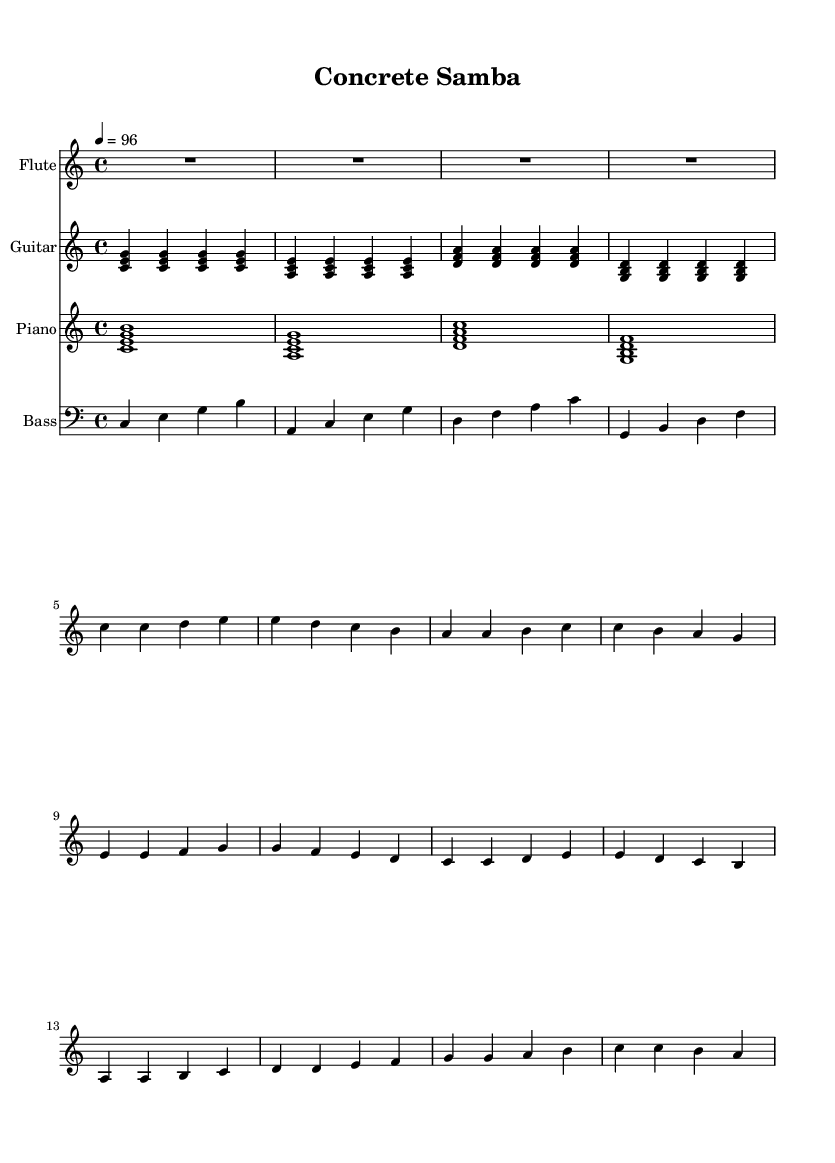What is the key signature of this music? The key signature is C major, indicated by the absence of sharps or flats.
Answer: C major What is the time signature of this piece? The time signature is found at the beginning of the score and shows 4/4, meaning there are four beats per measure.
Answer: 4/4 What is the tempo marking of this music? The tempo marking is indicated by "4 = 96", which means there are 96 beats per minute, suggesting a moderate pace.
Answer: 96 How many measures are in the flute part? By counting the distinct sections separated by the vertical bar lines, we find a total of 8 measures in the flute part.
Answer: 8 Which instrument plays the lowest pitch? By reviewing the parts, the bass instrument has the notes that are in the lower register, thus it plays the lowest pitch.
Answer: Bass Which chord is played in the first measure of the guitar part? The chord in the first measure of the guitar part is formed by the notes C, E, and G, making it a C major chord.
Answer: C major What is the primary structure of the composition based on the instruments included? The composition features a combination of flute, guitar, piano, and bass, typical of Bossa Nova, emphasizing rich harmonic textures.
Answer: Bossa Nova 